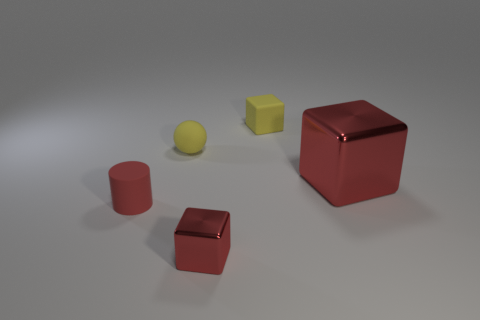Are there any cubes of the same color as the small matte cylinder?
Ensure brevity in your answer.  Yes. What size is the cube that is the same color as the sphere?
Your answer should be compact. Small. What number of other things are made of the same material as the sphere?
Offer a very short reply. 2. Are there any other things that are the same size as the yellow sphere?
Make the answer very short. Yes. Is the size of the yellow object that is in front of the yellow rubber cube the same as the red cylinder in front of the big object?
Provide a short and direct response. Yes. There is a cube to the left of the small matte block; what size is it?
Your answer should be compact. Small. What is the material of the small cube that is the same color as the cylinder?
Provide a succinct answer. Metal. The rubber sphere that is the same size as the red matte cylinder is what color?
Offer a terse response. Yellow. Is the size of the yellow matte sphere the same as the matte cube?
Your answer should be compact. Yes. There is a red object that is to the right of the matte cylinder and behind the small shiny object; what is its size?
Make the answer very short. Large. 